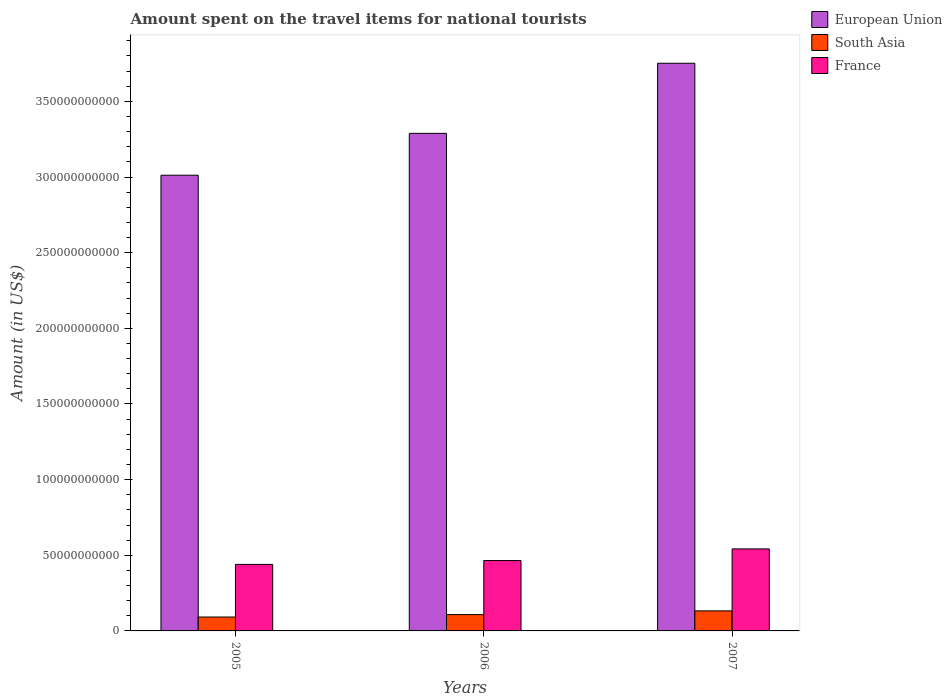How many different coloured bars are there?
Provide a succinct answer. 3. How many bars are there on the 3rd tick from the left?
Offer a terse response. 3. What is the amount spent on the travel items for national tourists in France in 2005?
Ensure brevity in your answer.  4.40e+1. Across all years, what is the maximum amount spent on the travel items for national tourists in France?
Offer a very short reply. 5.42e+1. Across all years, what is the minimum amount spent on the travel items for national tourists in France?
Offer a terse response. 4.40e+1. What is the total amount spent on the travel items for national tourists in South Asia in the graph?
Your response must be concise. 3.32e+1. What is the difference between the amount spent on the travel items for national tourists in South Asia in 2006 and that in 2007?
Make the answer very short. -2.46e+09. What is the difference between the amount spent on the travel items for national tourists in South Asia in 2007 and the amount spent on the travel items for national tourists in France in 2006?
Keep it short and to the point. -3.33e+1. What is the average amount spent on the travel items for national tourists in South Asia per year?
Ensure brevity in your answer.  1.11e+1. In the year 2006, what is the difference between the amount spent on the travel items for national tourists in France and amount spent on the travel items for national tourists in South Asia?
Your answer should be very brief. 3.57e+1. What is the ratio of the amount spent on the travel items for national tourists in South Asia in 2005 to that in 2007?
Keep it short and to the point. 0.69. Is the amount spent on the travel items for national tourists in South Asia in 2005 less than that in 2006?
Give a very brief answer. Yes. Is the difference between the amount spent on the travel items for national tourists in France in 2005 and 2006 greater than the difference between the amount spent on the travel items for national tourists in South Asia in 2005 and 2006?
Provide a succinct answer. No. What is the difference between the highest and the second highest amount spent on the travel items for national tourists in South Asia?
Offer a terse response. 2.46e+09. What is the difference between the highest and the lowest amount spent on the travel items for national tourists in South Asia?
Provide a succinct answer. 4.07e+09. Is the sum of the amount spent on the travel items for national tourists in South Asia in 2006 and 2007 greater than the maximum amount spent on the travel items for national tourists in France across all years?
Your response must be concise. No. What does the 2nd bar from the left in 2005 represents?
Your answer should be compact. South Asia. How many bars are there?
Provide a short and direct response. 9. Are all the bars in the graph horizontal?
Offer a very short reply. No. Does the graph contain grids?
Give a very brief answer. No. Where does the legend appear in the graph?
Keep it short and to the point. Top right. How many legend labels are there?
Keep it short and to the point. 3. What is the title of the graph?
Keep it short and to the point. Amount spent on the travel items for national tourists. Does "Comoros" appear as one of the legend labels in the graph?
Give a very brief answer. No. What is the label or title of the X-axis?
Offer a terse response. Years. What is the label or title of the Y-axis?
Make the answer very short. Amount (in US$). What is the Amount (in US$) of European Union in 2005?
Give a very brief answer. 3.01e+11. What is the Amount (in US$) of South Asia in 2005?
Your response must be concise. 9.18e+09. What is the Amount (in US$) of France in 2005?
Make the answer very short. 4.40e+1. What is the Amount (in US$) of European Union in 2006?
Provide a short and direct response. 3.29e+11. What is the Amount (in US$) in South Asia in 2006?
Your answer should be compact. 1.08e+1. What is the Amount (in US$) in France in 2006?
Provide a succinct answer. 4.65e+1. What is the Amount (in US$) in European Union in 2007?
Your answer should be compact. 3.75e+11. What is the Amount (in US$) in South Asia in 2007?
Your answer should be very brief. 1.33e+1. What is the Amount (in US$) in France in 2007?
Your answer should be compact. 5.42e+1. Across all years, what is the maximum Amount (in US$) of European Union?
Give a very brief answer. 3.75e+11. Across all years, what is the maximum Amount (in US$) of South Asia?
Offer a very short reply. 1.33e+1. Across all years, what is the maximum Amount (in US$) of France?
Make the answer very short. 5.42e+1. Across all years, what is the minimum Amount (in US$) of European Union?
Your response must be concise. 3.01e+11. Across all years, what is the minimum Amount (in US$) in South Asia?
Your answer should be compact. 9.18e+09. Across all years, what is the minimum Amount (in US$) in France?
Keep it short and to the point. 4.40e+1. What is the total Amount (in US$) in European Union in the graph?
Your answer should be very brief. 1.01e+12. What is the total Amount (in US$) of South Asia in the graph?
Your response must be concise. 3.32e+1. What is the total Amount (in US$) of France in the graph?
Your answer should be compact. 1.45e+11. What is the difference between the Amount (in US$) in European Union in 2005 and that in 2006?
Give a very brief answer. -2.77e+1. What is the difference between the Amount (in US$) of South Asia in 2005 and that in 2006?
Offer a very short reply. -1.61e+09. What is the difference between the Amount (in US$) in France in 2005 and that in 2006?
Keep it short and to the point. -2.56e+09. What is the difference between the Amount (in US$) of European Union in 2005 and that in 2007?
Make the answer very short. -7.40e+1. What is the difference between the Amount (in US$) of South Asia in 2005 and that in 2007?
Your answer should be very brief. -4.07e+09. What is the difference between the Amount (in US$) of France in 2005 and that in 2007?
Your answer should be compact. -1.03e+1. What is the difference between the Amount (in US$) in European Union in 2006 and that in 2007?
Offer a very short reply. -4.63e+1. What is the difference between the Amount (in US$) of South Asia in 2006 and that in 2007?
Your response must be concise. -2.46e+09. What is the difference between the Amount (in US$) of France in 2006 and that in 2007?
Make the answer very short. -7.70e+09. What is the difference between the Amount (in US$) in European Union in 2005 and the Amount (in US$) in South Asia in 2006?
Offer a terse response. 2.90e+11. What is the difference between the Amount (in US$) of European Union in 2005 and the Amount (in US$) of France in 2006?
Provide a succinct answer. 2.55e+11. What is the difference between the Amount (in US$) of South Asia in 2005 and the Amount (in US$) of France in 2006?
Offer a very short reply. -3.73e+1. What is the difference between the Amount (in US$) in European Union in 2005 and the Amount (in US$) in South Asia in 2007?
Provide a succinct answer. 2.88e+11. What is the difference between the Amount (in US$) of European Union in 2005 and the Amount (in US$) of France in 2007?
Give a very brief answer. 2.47e+11. What is the difference between the Amount (in US$) of South Asia in 2005 and the Amount (in US$) of France in 2007?
Provide a short and direct response. -4.50e+1. What is the difference between the Amount (in US$) of European Union in 2006 and the Amount (in US$) of South Asia in 2007?
Provide a succinct answer. 3.16e+11. What is the difference between the Amount (in US$) in European Union in 2006 and the Amount (in US$) in France in 2007?
Provide a succinct answer. 2.75e+11. What is the difference between the Amount (in US$) of South Asia in 2006 and the Amount (in US$) of France in 2007?
Give a very brief answer. -4.34e+1. What is the average Amount (in US$) of European Union per year?
Give a very brief answer. 3.35e+11. What is the average Amount (in US$) of South Asia per year?
Keep it short and to the point. 1.11e+1. What is the average Amount (in US$) in France per year?
Make the answer very short. 4.82e+1. In the year 2005, what is the difference between the Amount (in US$) in European Union and Amount (in US$) in South Asia?
Your answer should be compact. 2.92e+11. In the year 2005, what is the difference between the Amount (in US$) in European Union and Amount (in US$) in France?
Provide a succinct answer. 2.57e+11. In the year 2005, what is the difference between the Amount (in US$) of South Asia and Amount (in US$) of France?
Your response must be concise. -3.48e+1. In the year 2006, what is the difference between the Amount (in US$) in European Union and Amount (in US$) in South Asia?
Keep it short and to the point. 3.18e+11. In the year 2006, what is the difference between the Amount (in US$) of European Union and Amount (in US$) of France?
Ensure brevity in your answer.  2.82e+11. In the year 2006, what is the difference between the Amount (in US$) of South Asia and Amount (in US$) of France?
Give a very brief answer. -3.57e+1. In the year 2007, what is the difference between the Amount (in US$) in European Union and Amount (in US$) in South Asia?
Offer a very short reply. 3.62e+11. In the year 2007, what is the difference between the Amount (in US$) of European Union and Amount (in US$) of France?
Your response must be concise. 3.21e+11. In the year 2007, what is the difference between the Amount (in US$) of South Asia and Amount (in US$) of France?
Your answer should be compact. -4.10e+1. What is the ratio of the Amount (in US$) of European Union in 2005 to that in 2006?
Provide a short and direct response. 0.92. What is the ratio of the Amount (in US$) in South Asia in 2005 to that in 2006?
Your answer should be compact. 0.85. What is the ratio of the Amount (in US$) of France in 2005 to that in 2006?
Your answer should be very brief. 0.94. What is the ratio of the Amount (in US$) of European Union in 2005 to that in 2007?
Make the answer very short. 0.8. What is the ratio of the Amount (in US$) in South Asia in 2005 to that in 2007?
Give a very brief answer. 0.69. What is the ratio of the Amount (in US$) of France in 2005 to that in 2007?
Offer a terse response. 0.81. What is the ratio of the Amount (in US$) in European Union in 2006 to that in 2007?
Your response must be concise. 0.88. What is the ratio of the Amount (in US$) in South Asia in 2006 to that in 2007?
Ensure brevity in your answer.  0.81. What is the ratio of the Amount (in US$) in France in 2006 to that in 2007?
Your answer should be compact. 0.86. What is the difference between the highest and the second highest Amount (in US$) in European Union?
Keep it short and to the point. 4.63e+1. What is the difference between the highest and the second highest Amount (in US$) in South Asia?
Make the answer very short. 2.46e+09. What is the difference between the highest and the second highest Amount (in US$) in France?
Keep it short and to the point. 7.70e+09. What is the difference between the highest and the lowest Amount (in US$) of European Union?
Keep it short and to the point. 7.40e+1. What is the difference between the highest and the lowest Amount (in US$) of South Asia?
Your response must be concise. 4.07e+09. What is the difference between the highest and the lowest Amount (in US$) in France?
Provide a succinct answer. 1.03e+1. 